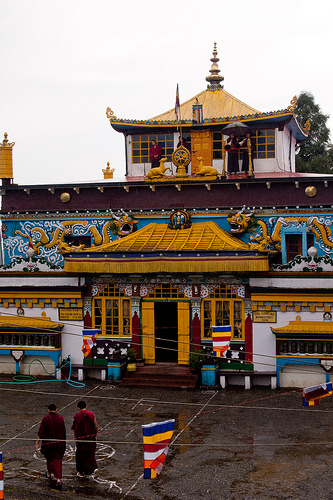<image>
Is there a man behind the window? No. The man is not behind the window. From this viewpoint, the man appears to be positioned elsewhere in the scene. Is the flag above the street? Yes. The flag is positioned above the street in the vertical space, higher up in the scene. 